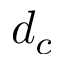Convert formula to latex. <formula><loc_0><loc_0><loc_500><loc_500>d _ { c }</formula> 